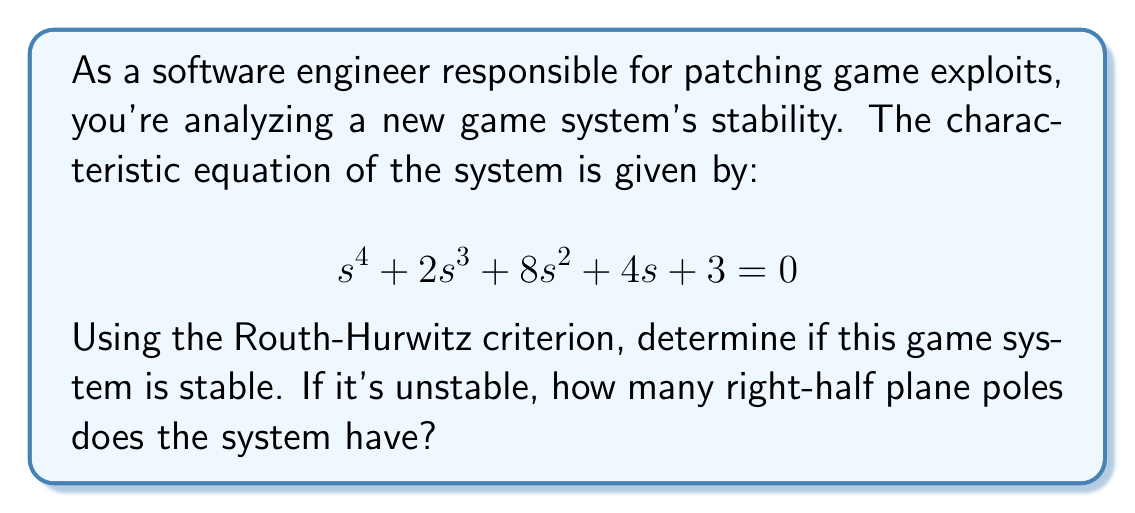Teach me how to tackle this problem. To determine the stability of the system using the Routh-Hurwitz criterion, we need to construct the Routh array and analyze it. Here's the step-by-step process:

1. Construct the Routh array:

   $$\begin{array}{c|cccc}
   s^4 & 1 & 8 & 3 \\
   s^3 & 2 & 4 & 0 \\
   s^2 & b_1 & b_2 & \\
   s^1 & c_1 & & \\
   s^0 & d_1 & &
   \end{array}$$

2. Calculate the values for the remaining rows:

   For $s^2$ row:
   $$b_1 = \frac{(2)(8) - (1)(4)}{2} = 6$$
   $$b_2 = \frac{(2)(3) - (1)(0)}{2} = 3$$

   For $s^1$ row:
   $$c_1 = \frac{(6)(4) - (2)(3)}{6} = 3$$

   For $s^0$ row:
   $$d_1 = 3$$ (same as $b_2$ since $c_1 \neq 0$)

3. The complete Routh array:

   $$\begin{array}{c|cccc}
   s^4 & 1 & 8 & 3 \\
   s^3 & 2 & 4 & 0 \\
   s^2 & 6 & 3 & \\
   s^1 & 3 & & \\
   s^0 & 3 & &
   \end{array}$$

4. Analyze the first column of the Routh array:
   - If there are no sign changes in the first column, the system is stable.
   - If there are sign changes, the number of sign changes equals the number of right-half plane poles.

In this case, we see that all coefficients in the first column are positive (1, 2, 6, 3, 3). There are no sign changes.

Therefore, the system is stable, as there are no right-half plane poles.
Answer: The game system is stable, with 0 right-half plane poles. 